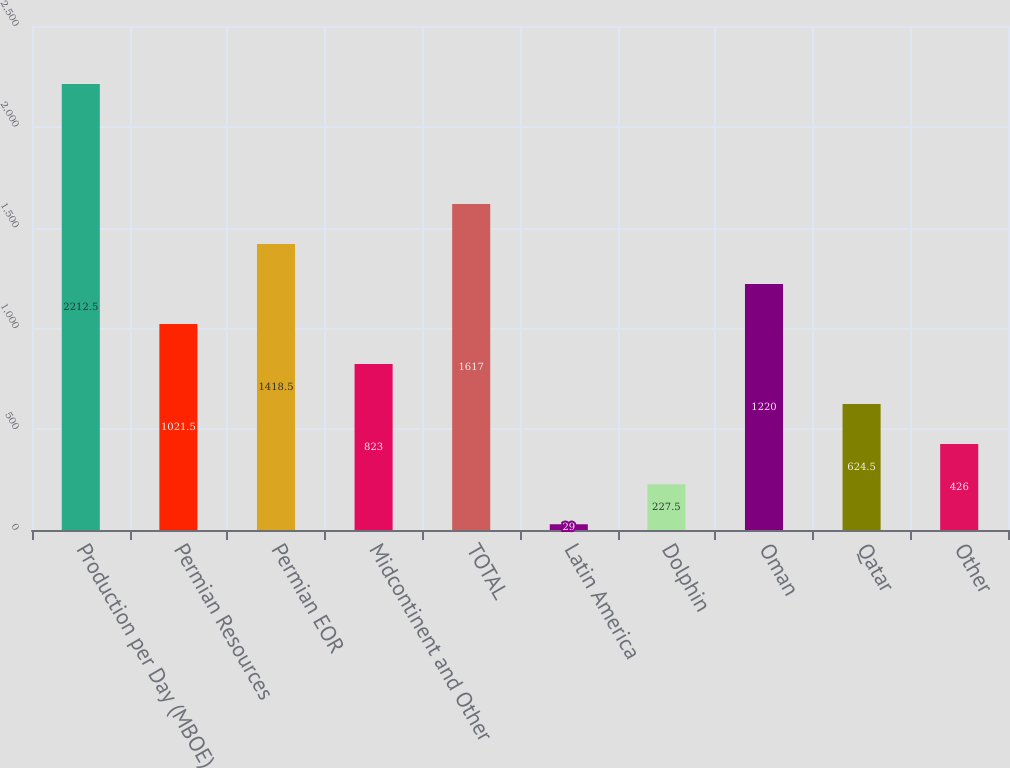Convert chart to OTSL. <chart><loc_0><loc_0><loc_500><loc_500><bar_chart><fcel>Production per Day (MBOE)<fcel>Permian Resources<fcel>Permian EOR<fcel>Midcontinent and Other<fcel>TOTAL<fcel>Latin America<fcel>Dolphin<fcel>Oman<fcel>Qatar<fcel>Other<nl><fcel>2212.5<fcel>1021.5<fcel>1418.5<fcel>823<fcel>1617<fcel>29<fcel>227.5<fcel>1220<fcel>624.5<fcel>426<nl></chart> 